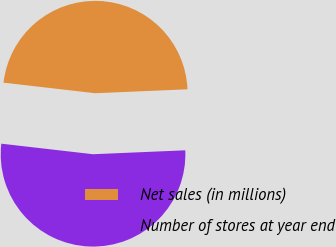Convert chart to OTSL. <chart><loc_0><loc_0><loc_500><loc_500><pie_chart><fcel>Net sales (in millions)<fcel>Number of stores at year end<nl><fcel>47.5%<fcel>52.5%<nl></chart> 